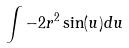Convert formula to latex. <formula><loc_0><loc_0><loc_500><loc_500>\int - 2 r ^ { 2 } \sin ( u ) d u</formula> 